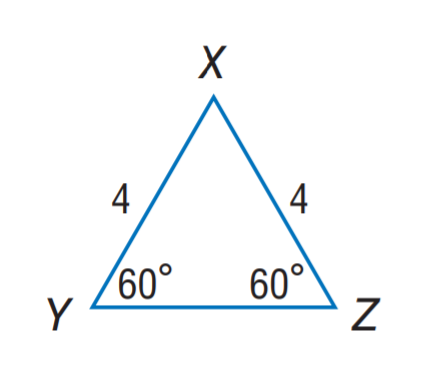Question: Find Y Z.
Choices:
A. 2
B. 4
C. 6
D. 8
Answer with the letter. Answer: B 